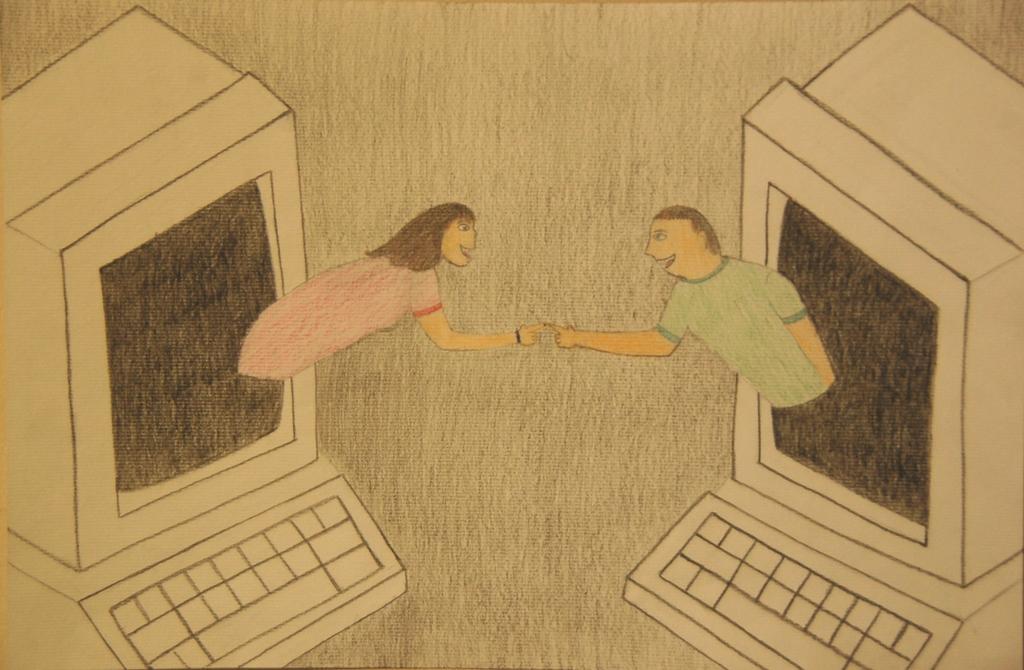How would you summarize this image in a sentence or two? In this picture there is a painting of a couple coming out of a desktop which is in left and right corners and there is a keyboard below the desktop. 